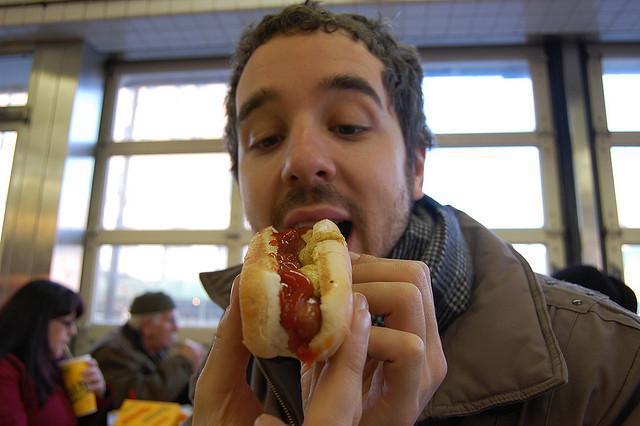How many people are visible?
Give a very brief answer. 3. How many hot dogs are visible?
Give a very brief answer. 1. How many zebras can you see?
Give a very brief answer. 0. 